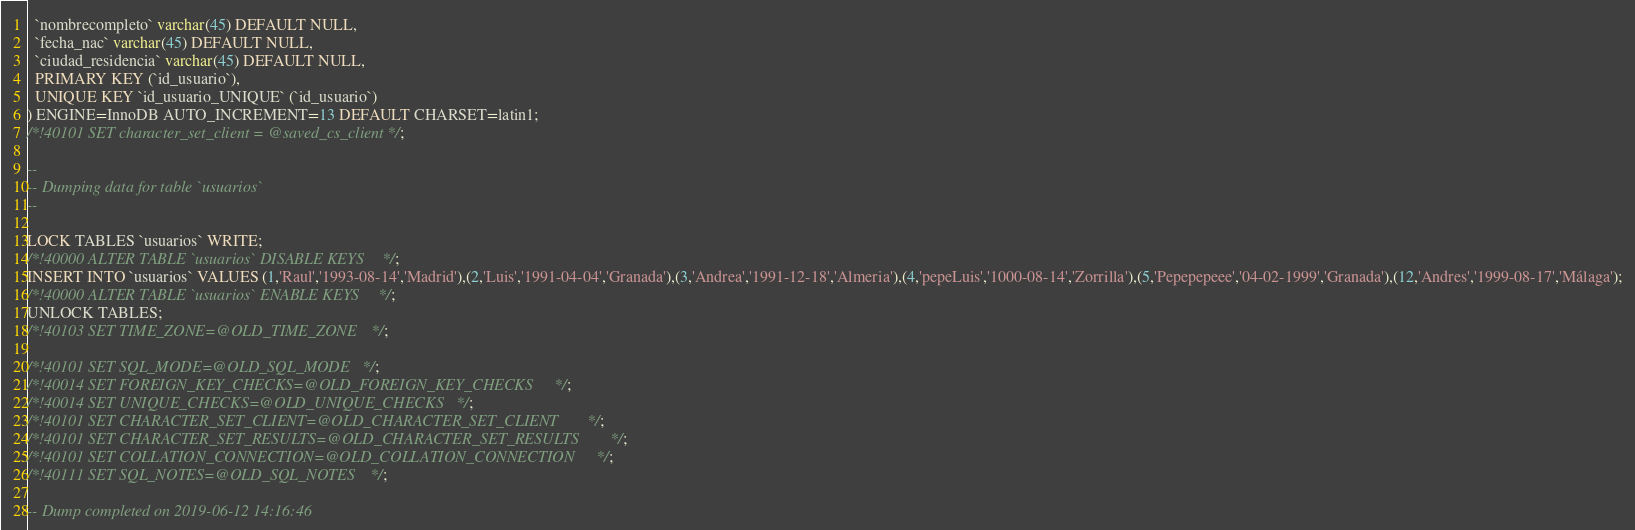<code> <loc_0><loc_0><loc_500><loc_500><_SQL_>  `nombrecompleto` varchar(45) DEFAULT NULL,
  `fecha_nac` varchar(45) DEFAULT NULL,
  `ciudad_residencia` varchar(45) DEFAULT NULL,
  PRIMARY KEY (`id_usuario`),
  UNIQUE KEY `id_usuario_UNIQUE` (`id_usuario`)
) ENGINE=InnoDB AUTO_INCREMENT=13 DEFAULT CHARSET=latin1;
/*!40101 SET character_set_client = @saved_cs_client */;

--
-- Dumping data for table `usuarios`
--

LOCK TABLES `usuarios` WRITE;
/*!40000 ALTER TABLE `usuarios` DISABLE KEYS */;
INSERT INTO `usuarios` VALUES (1,'Raul','1993-08-14','Madrid'),(2,'Luis','1991-04-04','Granada'),(3,'Andrea','1991-12-18','Almeria'),(4,'pepeLuis','1000-08-14','Zorrilla'),(5,'Pepepepeee','04-02-1999','Granada'),(12,'Andres','1999-08-17','Málaga');
/*!40000 ALTER TABLE `usuarios` ENABLE KEYS */;
UNLOCK TABLES;
/*!40103 SET TIME_ZONE=@OLD_TIME_ZONE */;

/*!40101 SET SQL_MODE=@OLD_SQL_MODE */;
/*!40014 SET FOREIGN_KEY_CHECKS=@OLD_FOREIGN_KEY_CHECKS */;
/*!40014 SET UNIQUE_CHECKS=@OLD_UNIQUE_CHECKS */;
/*!40101 SET CHARACTER_SET_CLIENT=@OLD_CHARACTER_SET_CLIENT */;
/*!40101 SET CHARACTER_SET_RESULTS=@OLD_CHARACTER_SET_RESULTS */;
/*!40101 SET COLLATION_CONNECTION=@OLD_COLLATION_CONNECTION */;
/*!40111 SET SQL_NOTES=@OLD_SQL_NOTES */;

-- Dump completed on 2019-06-12 14:16:46
</code> 